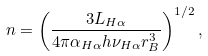Convert formula to latex. <formula><loc_0><loc_0><loc_500><loc_500>n = \left ( \frac { 3 L _ { H \alpha } } { 4 \pi \alpha _ { H \alpha } h \nu _ { H \alpha } r _ { B } ^ { 3 } } \right ) ^ { 1 / 2 } ,</formula> 